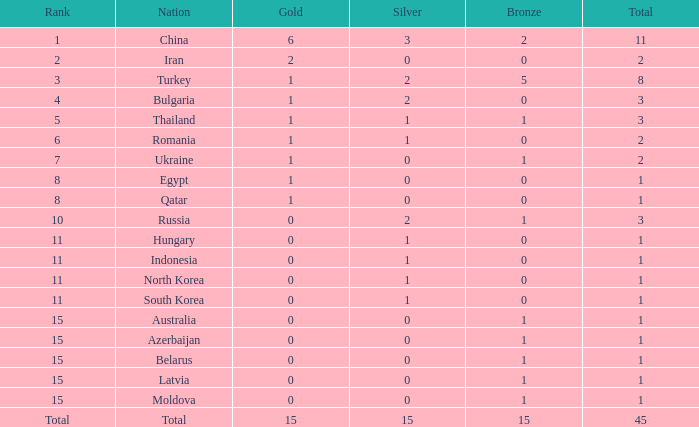What is the greatest number of bronze china, with more than 1 gold and above 11 overall, holds? None. 